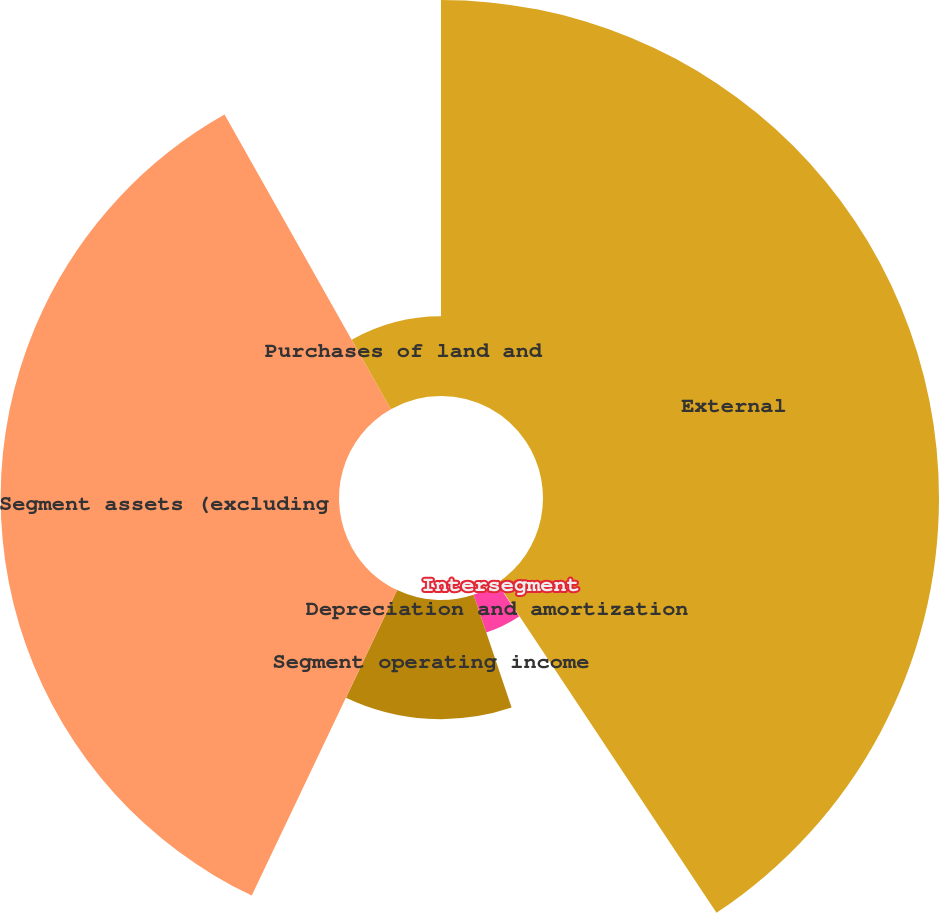Convert chart to OTSL. <chart><loc_0><loc_0><loc_500><loc_500><pie_chart><fcel>External<fcel>Intersegment<fcel>Depreciation and amortization<fcel>Segment operating income<fcel>Segment assets (excluding<fcel>Purchases of land and<nl><fcel>40.67%<fcel>0.05%<fcel>4.11%<fcel>12.24%<fcel>34.75%<fcel>8.18%<nl></chart> 